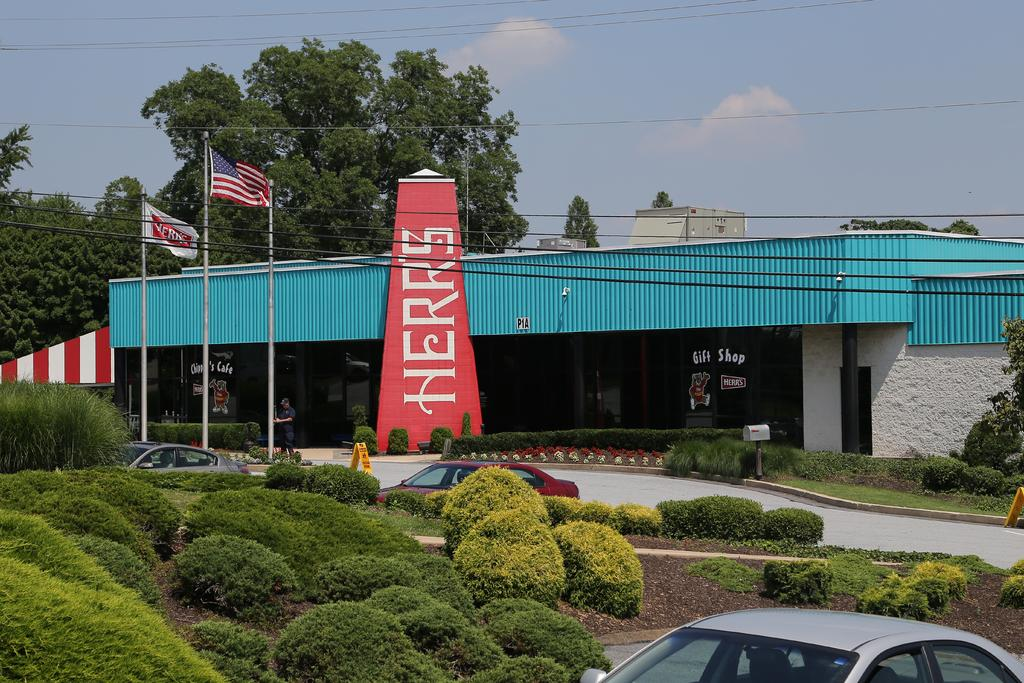What type of establishment can be seen in the image? There is a store in the image. What is located near the store? There is a pole in the image. What is attached to the pole? There is a flag in the image. What mode of transportation is present in the image? There is a vehicle in the image. What type of natural environment is visible in the image? Soil, plants, grass, and trees are visible in the image. What is the condition of the sky in the image? The sky is cloudy and blue in the image. Is there a person present in the image? Yes, there is a person standing in the image. What is the person wearing? The person is wearing clothes. What else can be seen in the image related to infrastructure? There are electric wires in the image. Where is the square located in the image? There is no square present in the image. What type of flame can be seen coming from the vehicle in the image? There is no flame coming from the vehicle in the image. 